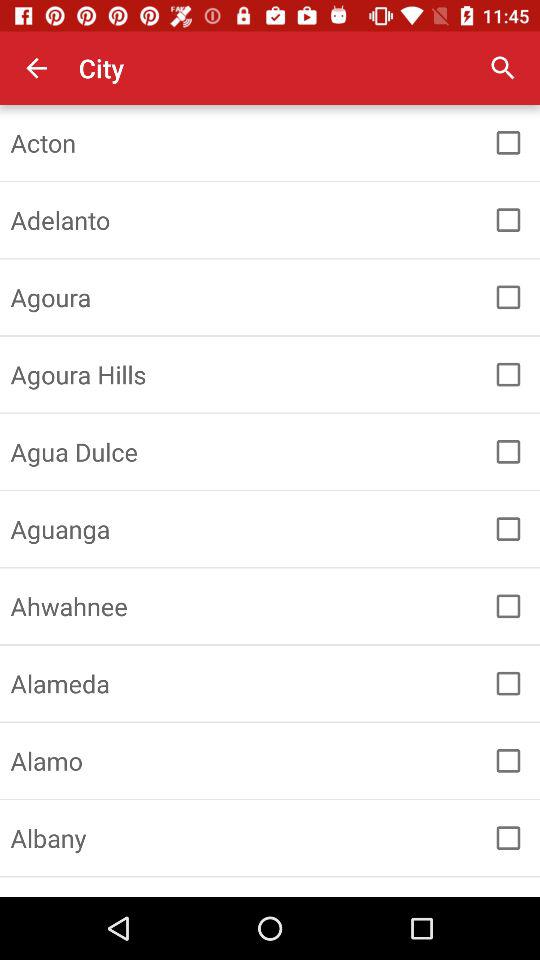What is the status of the Aguanga? The status is off. 